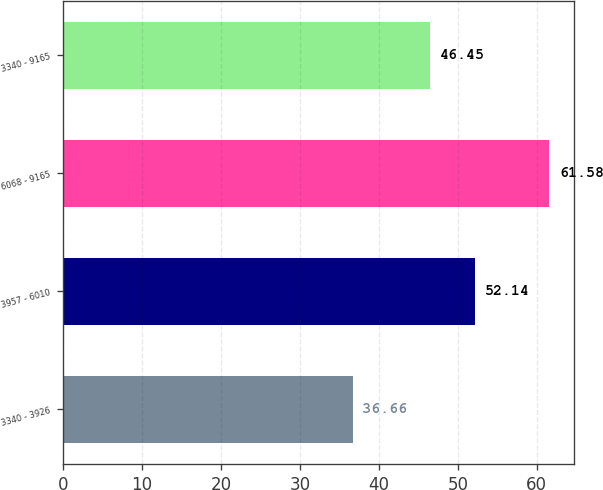<chart> <loc_0><loc_0><loc_500><loc_500><bar_chart><fcel>3340 - 3926<fcel>3957 - 6010<fcel>6068 - 9165<fcel>3340 - 9165<nl><fcel>36.66<fcel>52.14<fcel>61.58<fcel>46.45<nl></chart> 